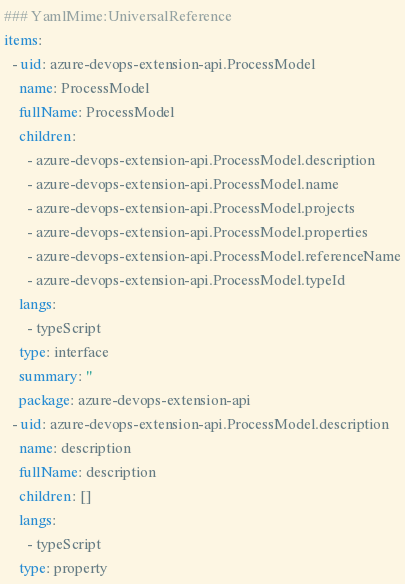<code> <loc_0><loc_0><loc_500><loc_500><_YAML_>### YamlMime:UniversalReference
items:
  - uid: azure-devops-extension-api.ProcessModel
    name: ProcessModel
    fullName: ProcessModel
    children:
      - azure-devops-extension-api.ProcessModel.description
      - azure-devops-extension-api.ProcessModel.name
      - azure-devops-extension-api.ProcessModel.projects
      - azure-devops-extension-api.ProcessModel.properties
      - azure-devops-extension-api.ProcessModel.referenceName
      - azure-devops-extension-api.ProcessModel.typeId
    langs:
      - typeScript
    type: interface
    summary: ''
    package: azure-devops-extension-api
  - uid: azure-devops-extension-api.ProcessModel.description
    name: description
    fullName: description
    children: []
    langs:
      - typeScript
    type: property</code> 